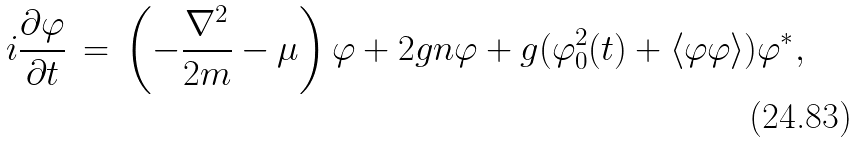Convert formula to latex. <formula><loc_0><loc_0><loc_500><loc_500>i \frac { \partial \varphi } { \partial t } \, = \, \left ( - \frac { \nabla ^ { 2 } } { 2 m } - \mu \right ) \varphi + 2 g n \varphi + g ( \varphi _ { 0 } ^ { 2 } ( t ) + \langle \varphi \varphi \rangle ) \varphi ^ { * } ,</formula> 